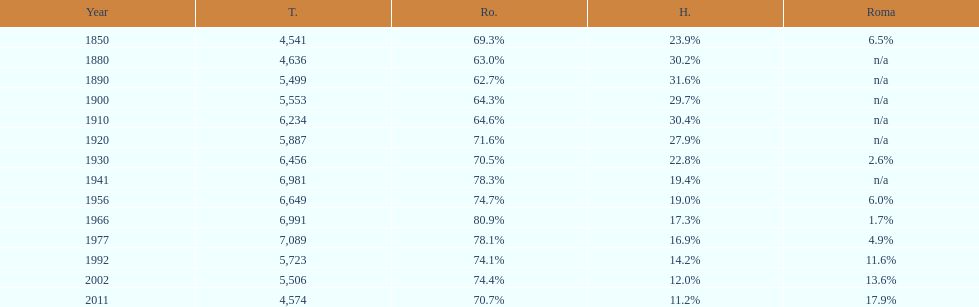What year had the highest total number? 1977. 